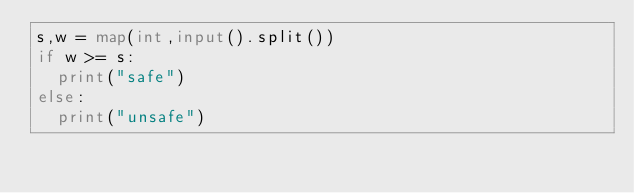Convert code to text. <code><loc_0><loc_0><loc_500><loc_500><_Python_>s,w = map(int,input().split())
if w >= s:
  print("safe")
else:
  print("unsafe")</code> 